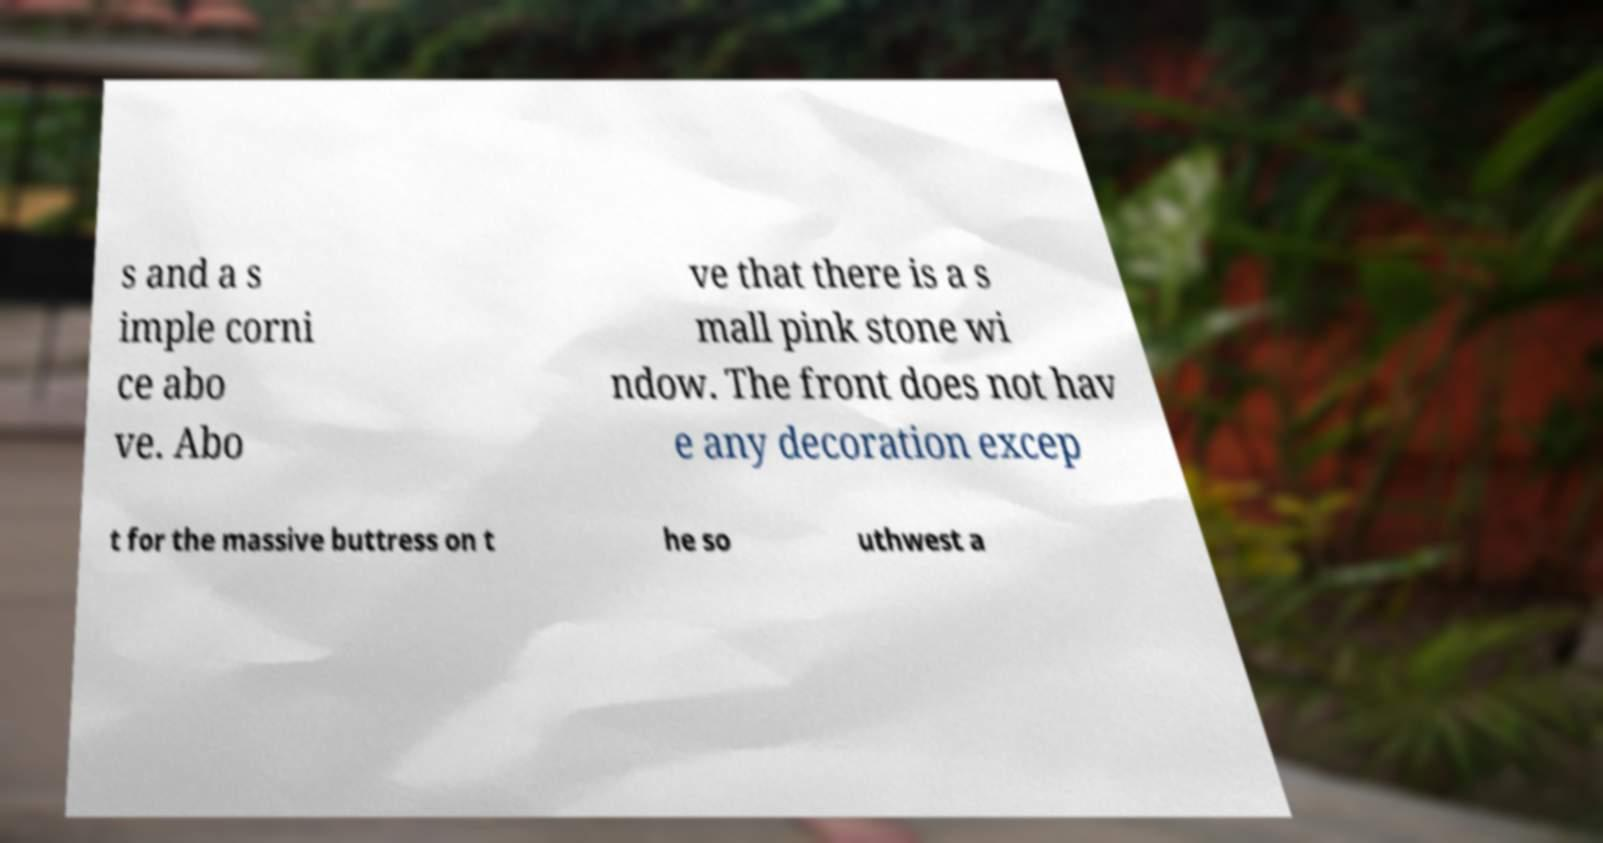I need the written content from this picture converted into text. Can you do that? s and a s imple corni ce abo ve. Abo ve that there is a s mall pink stone wi ndow. The front does not hav e any decoration excep t for the massive buttress on t he so uthwest a 